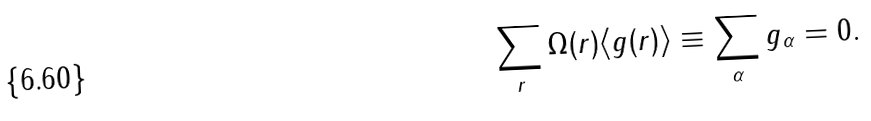Convert formula to latex. <formula><loc_0><loc_0><loc_500><loc_500>\sum _ { r } \Omega ( { r } ) \langle g ( { r } ) \rangle \equiv \sum _ { \alpha } g _ { \alpha } = 0 .</formula> 